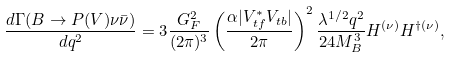Convert formula to latex. <formula><loc_0><loc_0><loc_500><loc_500>\frac { d \Gamma ( B \to P ( V ) \nu \bar { \nu } ) } { d q ^ { 2 } } = 3 \frac { G _ { F } ^ { 2 } } { ( 2 \pi ) ^ { 3 } } \left ( \frac { \alpha | V _ { t f } ^ { * } V _ { t b } | } { 2 \pi } \right ) ^ { 2 } \frac { \lambda ^ { 1 / 2 } q ^ { 2 } } { 2 4 M _ { B } ^ { 3 } } H ^ { ( \nu ) } H ^ { \dag ( \nu ) } ,</formula> 